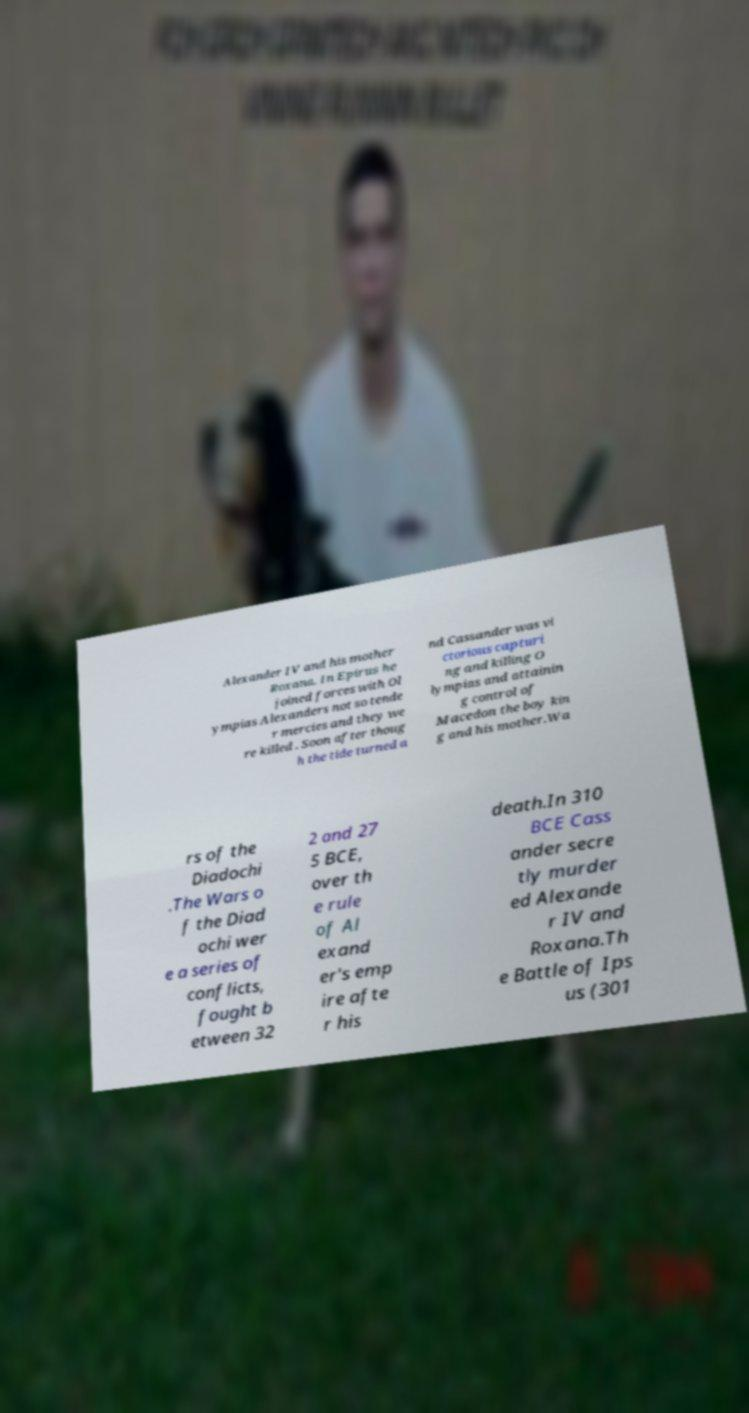Could you assist in decoding the text presented in this image and type it out clearly? Alexander IV and his mother Roxana. In Epirus he joined forces with Ol ympias Alexanders not so tende r mercies and they we re killed . Soon after thoug h the tide turned a nd Cassander was vi ctorious capturi ng and killing O lympias and attainin g control of Macedon the boy kin g and his mother.Wa rs of the Diadochi .The Wars o f the Diad ochi wer e a series of conflicts, fought b etween 32 2 and 27 5 BCE, over th e rule of Al exand er's emp ire afte r his death.In 310 BCE Cass ander secre tly murder ed Alexande r IV and Roxana.Th e Battle of Ips us (301 